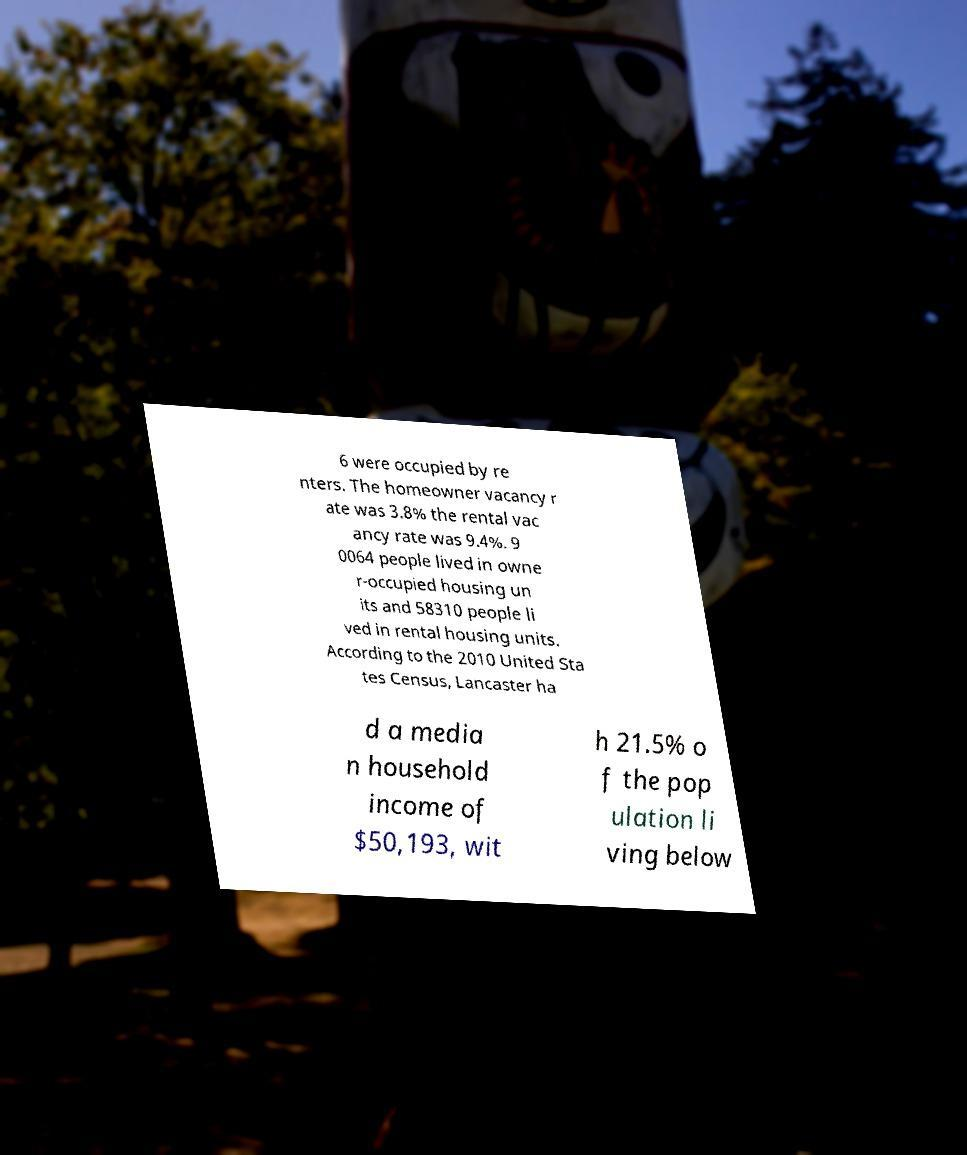There's text embedded in this image that I need extracted. Can you transcribe it verbatim? 6 were occupied by re nters. The homeowner vacancy r ate was 3.8% the rental vac ancy rate was 9.4%. 9 0064 people lived in owne r-occupied housing un its and 58310 people li ved in rental housing units. According to the 2010 United Sta tes Census, Lancaster ha d a media n household income of $50,193, wit h 21.5% o f the pop ulation li ving below 